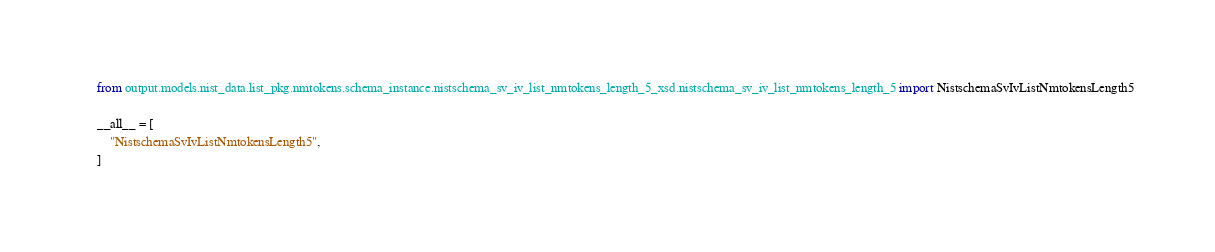<code> <loc_0><loc_0><loc_500><loc_500><_Python_>from output.models.nist_data.list_pkg.nmtokens.schema_instance.nistschema_sv_iv_list_nmtokens_length_5_xsd.nistschema_sv_iv_list_nmtokens_length_5 import NistschemaSvIvListNmtokensLength5

__all__ = [
    "NistschemaSvIvListNmtokensLength5",
]
</code> 